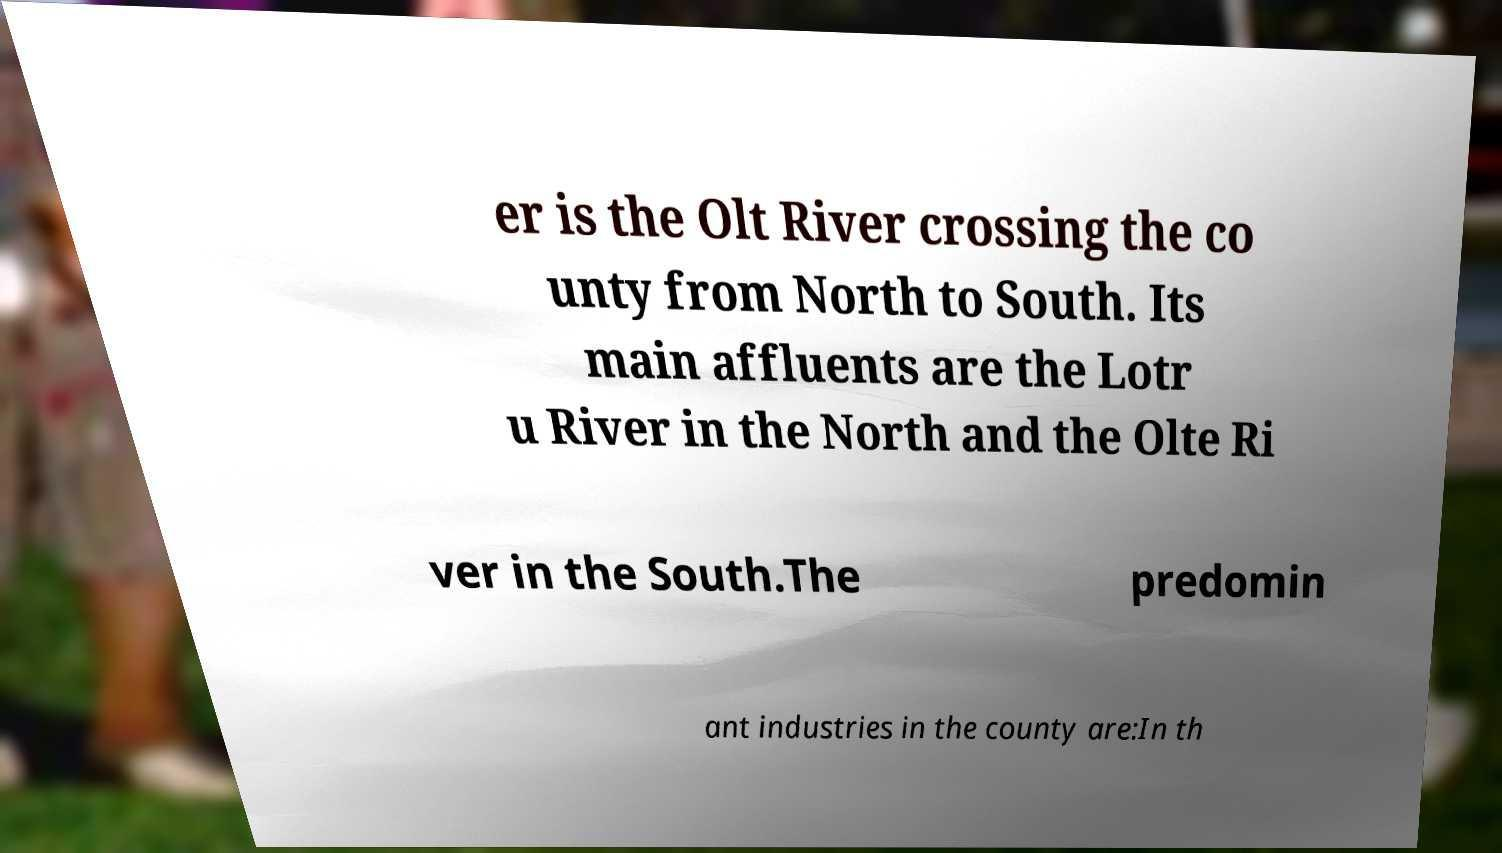Please read and relay the text visible in this image. What does it say? er is the Olt River crossing the co unty from North to South. Its main affluents are the Lotr u River in the North and the Olte Ri ver in the South.The predomin ant industries in the county are:In th 